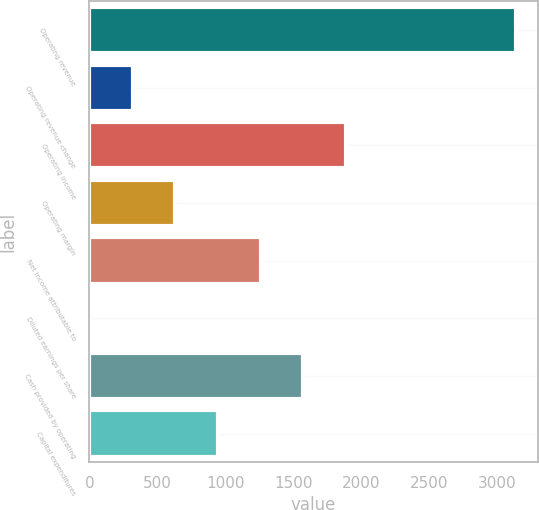Convert chart. <chart><loc_0><loc_0><loc_500><loc_500><bar_chart><fcel>Operating revenue<fcel>Operating revenue change<fcel>Operating income<fcel>Operating margin<fcel>Net income attributable to<fcel>Diluted earnings per share<fcel>Cash provided by operating<fcel>Capital expenditures<nl><fcel>3144.9<fcel>318.13<fcel>1888.58<fcel>632.22<fcel>1260.4<fcel>4.04<fcel>1574.49<fcel>946.31<nl></chart> 